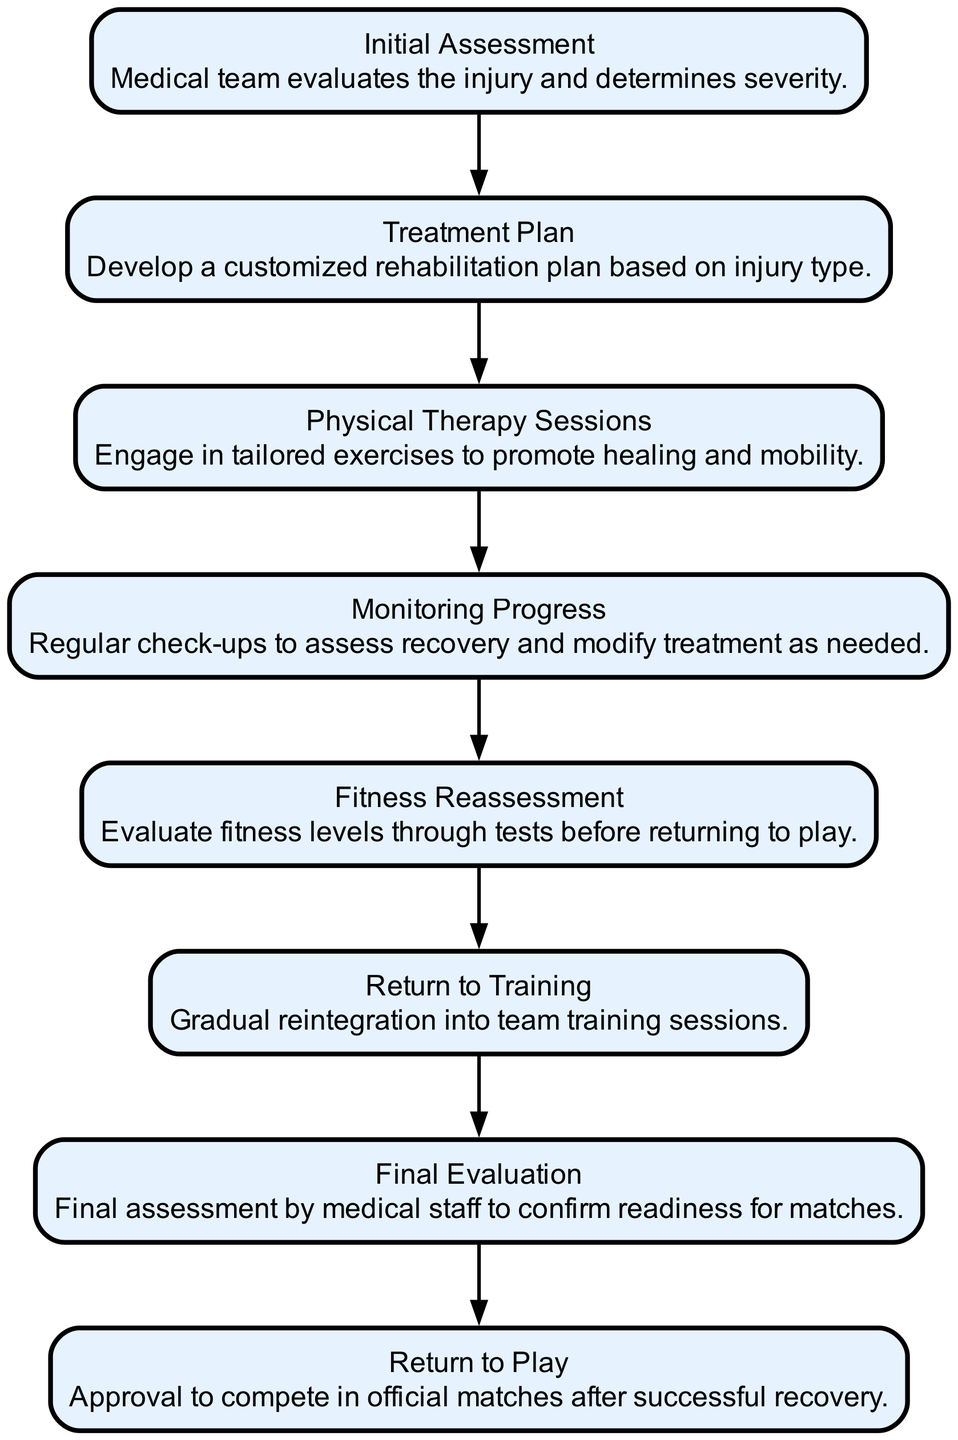What is the first step in the injury recovery process? The first step, as represented in the diagram, is "Initial Assessment", where the medical team evaluates the injury and determines its severity.
Answer: Initial Assessment How many steps are there in the injury recovery process? Counting all the nodes in the flow chart, there are a total of eight steps, from Initial Assessment to Return to Play.
Answer: Eight What comes after Physical Therapy Sessions? In the sequence of steps, the next node after Physical Therapy Sessions is "Monitoring Progress". This indicates that after the therapy sessions, the player's progress is monitored before moving to the next stage.
Answer: Monitoring Progress What is the final step before a player can return to play? The step just before a player can return to play is the "Final Evaluation", where medical staff assess readiness for matches to ensure the player is fit.
Answer: Final Evaluation If monitoring progress indicates issues, what is the implication for the treatment plan? When issues are identified during "Monitoring Progress", the treatment plan may need to be modified, suggesting that the recovery process is not linear and may require adjustments.
Answer: Modify Treatment Plan Which step involves a gradual reintegration into team activities? The step titled "Return to Training" specifically denotes the gradual reintegration of the player into team training sessions, preparing them for full involvement.
Answer: Return to Training What does the fitness reassessment evaluate? "Fitness Reassessment" evaluates the player's fitness levels through tests before they are allowed to return to play. This ensures that the player meets the required physical condition for playing matches.
Answer: Fitness Levels What is the purpose of the initial assessment? The purpose of "Initial Assessment" is to have the medical team evaluate the injury and determine its severity, setting the foundation for the entire recovery process.
Answer: Evaluate Injury Severity 